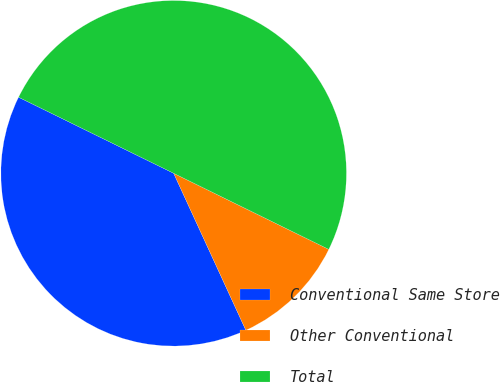Convert chart to OTSL. <chart><loc_0><loc_0><loc_500><loc_500><pie_chart><fcel>Conventional Same Store<fcel>Other Conventional<fcel>Total<nl><fcel>39.12%<fcel>10.88%<fcel>50.0%<nl></chart> 